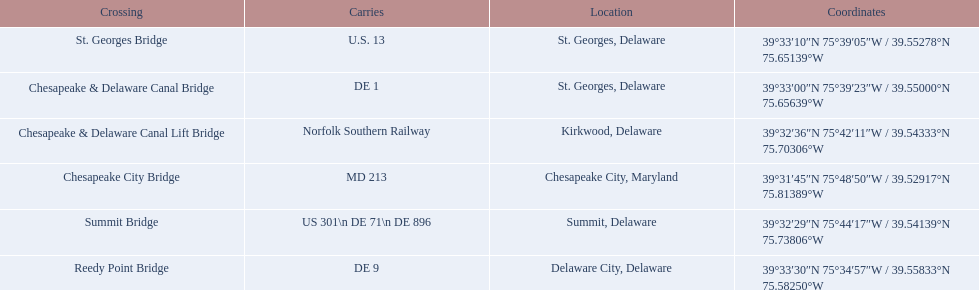Which bridge has their location in summit, delaware? Summit Bridge. 